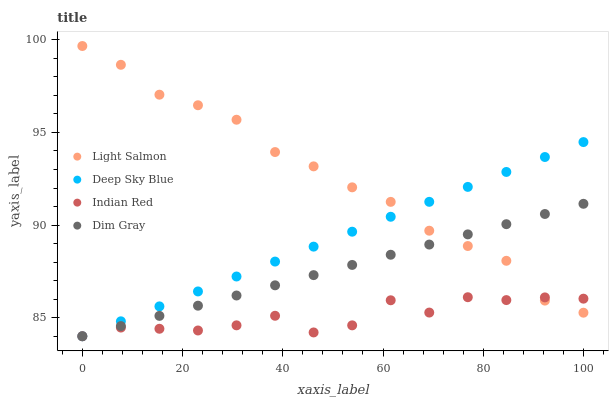Does Indian Red have the minimum area under the curve?
Answer yes or no. Yes. Does Light Salmon have the maximum area under the curve?
Answer yes or no. Yes. Does Dim Gray have the minimum area under the curve?
Answer yes or no. No. Does Dim Gray have the maximum area under the curve?
Answer yes or no. No. Is Deep Sky Blue the smoothest?
Answer yes or no. Yes. Is Indian Red the roughest?
Answer yes or no. Yes. Is Dim Gray the smoothest?
Answer yes or no. No. Is Dim Gray the roughest?
Answer yes or no. No. Does Dim Gray have the lowest value?
Answer yes or no. Yes. Does Light Salmon have the highest value?
Answer yes or no. Yes. Does Dim Gray have the highest value?
Answer yes or no. No. Does Deep Sky Blue intersect Dim Gray?
Answer yes or no. Yes. Is Deep Sky Blue less than Dim Gray?
Answer yes or no. No. Is Deep Sky Blue greater than Dim Gray?
Answer yes or no. No. 